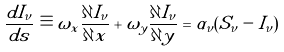<formula> <loc_0><loc_0><loc_500><loc_500>\frac { d I _ { \nu } } { d s } \equiv \omega _ { x } \frac { \partial I _ { \nu } } { \partial x } + \omega _ { y } \frac { \partial I _ { \nu } } { \partial y } = \alpha _ { \nu } ( S _ { \nu } - I _ { \nu } )</formula> 